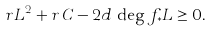Convert formula to latex. <formula><loc_0><loc_0><loc_500><loc_500>r L ^ { 2 } + r \, C - 2 d \, \deg f _ { * } L \geq 0 .</formula> 